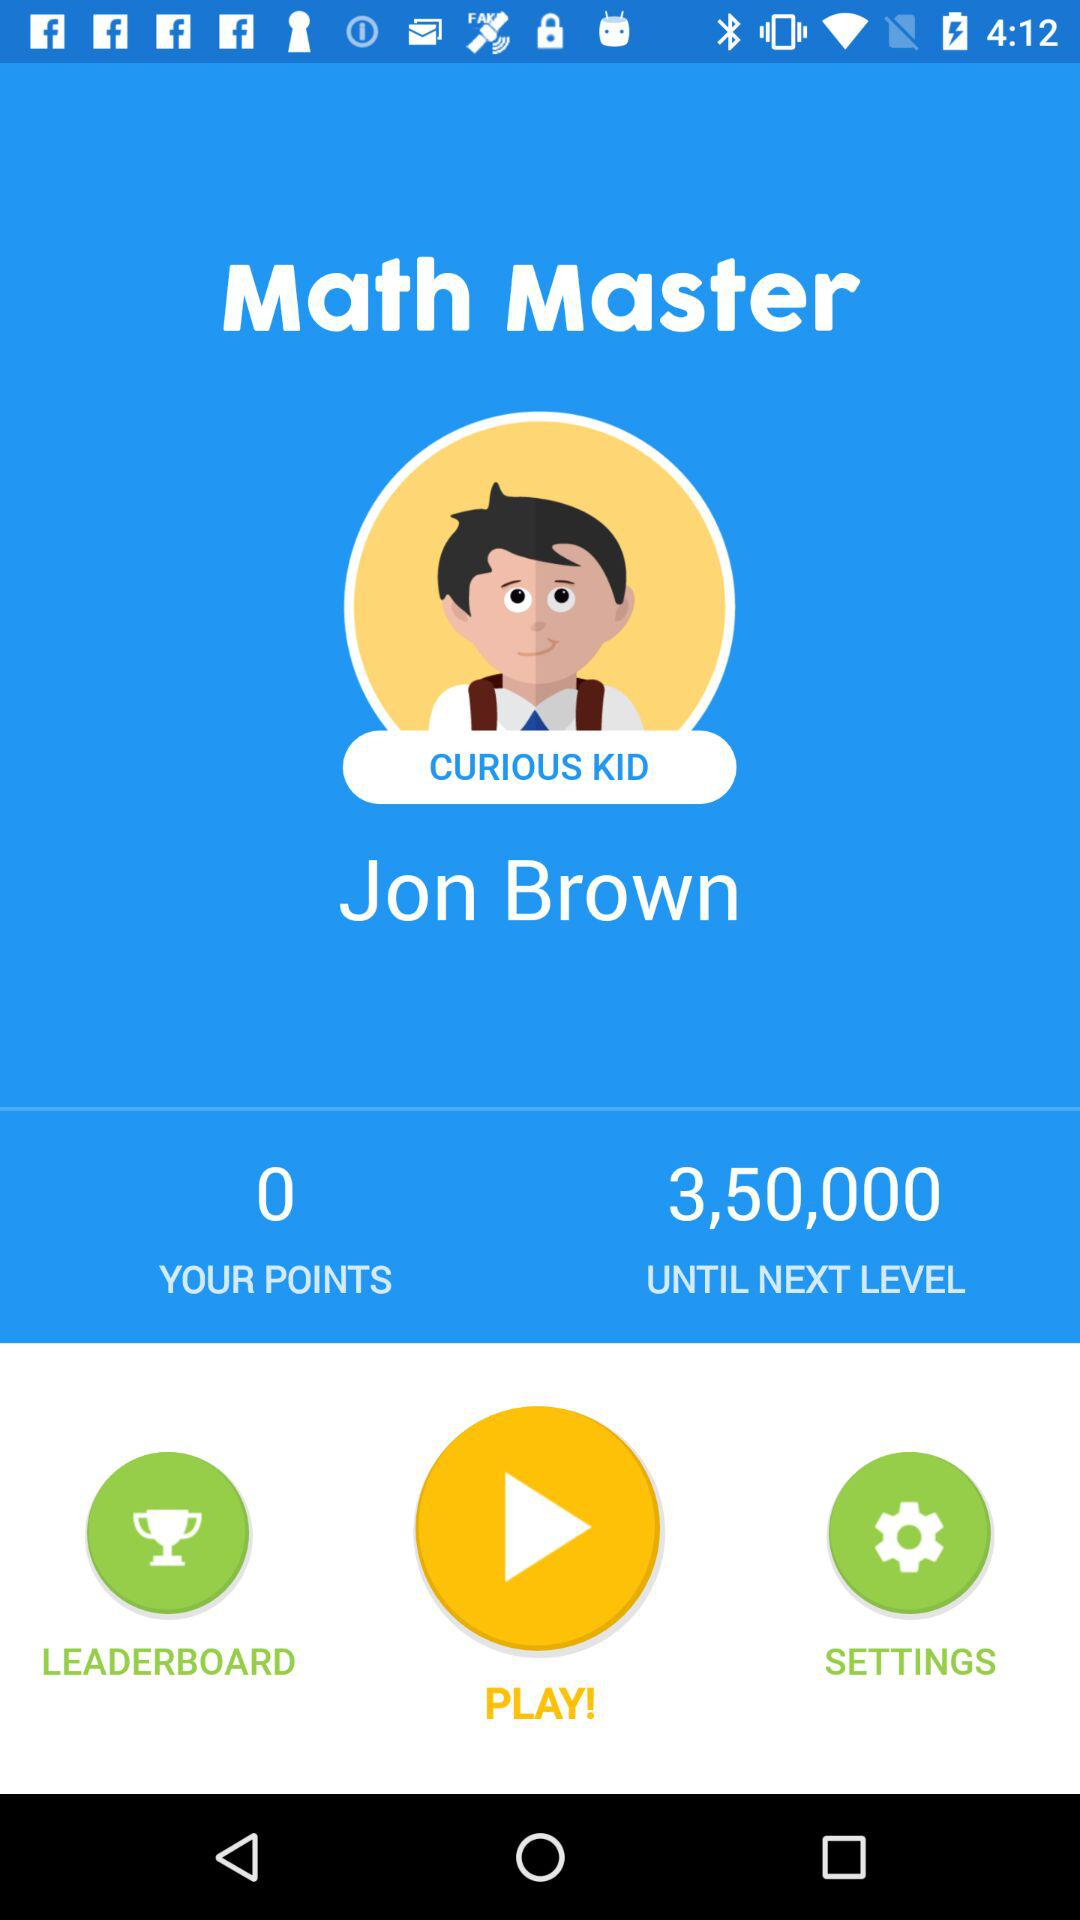How many points does Jon Brown have? Jon Brown has 0 points. 